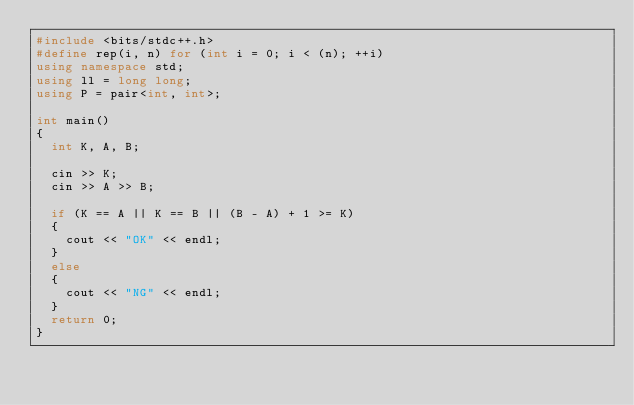Convert code to text. <code><loc_0><loc_0><loc_500><loc_500><_C++_>#include <bits/stdc++.h>
#define rep(i, n) for (int i = 0; i < (n); ++i)
using namespace std;
using ll = long long;
using P = pair<int, int>;

int main()
{
  int K, A, B;

  cin >> K;
  cin >> A >> B;

  if (K == A || K == B || (B - A) + 1 >= K)
  {
    cout << "OK" << endl;
  }
  else
  {
    cout << "NG" << endl;
  }
  return 0;
}
</code> 